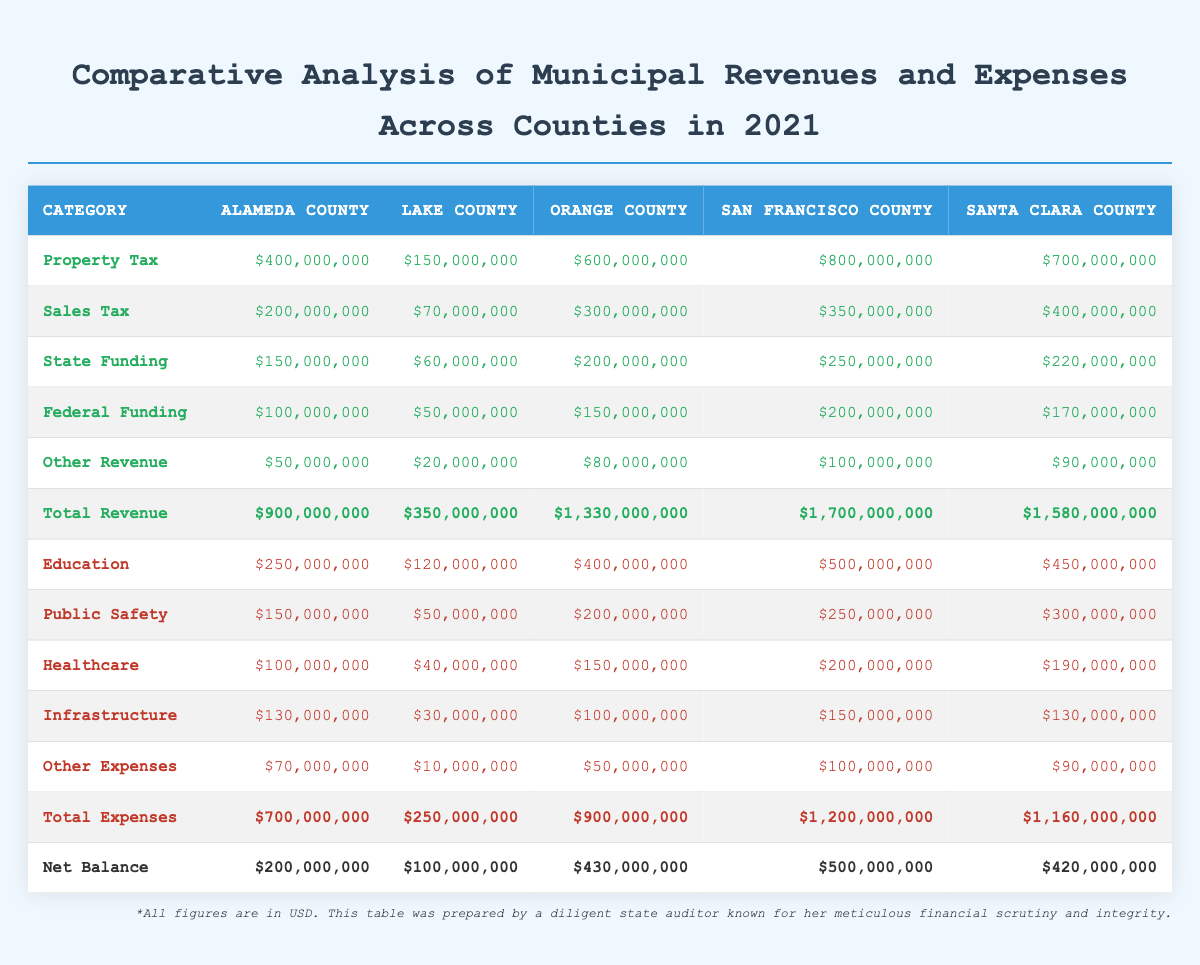What is the total revenue for Orange County? The total revenue for Orange County is provided directly in the table under the "Total Revenue" row, which shows $1,330,000,000.
Answer: 1,330,000,000 Which county has the highest expenditure on education? By examining the "Education" expenses row, San Francisco County has the highest expenditure at $500,000,000.
Answer: San Francisco County What is the difference in total expenses between Santa Clara County and Lake County? Santa Clara County's total expenses are $1,160,000,000 and Lake County's are $250,000,000. The difference is calculated as $1,160,000,000 - $250,000,000 = $910,000,000.
Answer: 910,000,000 Is the total revenue of Alameda County greater than the total revenue of Lake County? Alameda County's total revenue is $900,000,000 while Lake County's is $350,000,000, so yes, Alameda County's total revenue is greater.
Answer: Yes Which county has the highest net balance, and what is that amount? The net balance is calculated under the "Net Balance" row, and San Francisco County has the highest net balance at $500,000,000.
Answer: San Francisco County, 500,000,000 What percentage of Alameda County’s total revenue is sourced from property tax? The property tax for Alameda County is $400,000,000, and total revenue is $900,000,000. The percentage is calculated as ($400,000,000 / $900,000,000) * 100 = approximately 44.44%.
Answer: 44.44% What is the total funding (state and federal) for Santa Clara County? The state funding for Santa Clara County is $220,000,000 and federal funding is $170,000,000. Adding both gives us $220,000,000 + $170,000,000 = $390,000,000.
Answer: 390,000,000 Does any county have more than $1 billion in combined revenue and expenses? For each county, combine their total revenue and total expenses: San Francisco County has $1,700,000,000 + $1,200,000,000 = $2,900,000,000, Santa Clara has $1,580,000,000 + $1,160,000,000 = $2,740,000,000, and Orange County has $1,330,000,000 + $900,000,000 = $2,230,000,000. Yes, several counties exceed $1 billion.
Answer: Yes What is the average total revenue across all counties? Total revenue for all counties is $900,000,000 (Alameda) + $350,000,000 (Lake) + $1,330,000,000 (Orange) + $1,700,000,000 (San Francisco) + $1,580,000,000 (Santa Clara) = $5,860,000,000. There are 5 counties, so the average is $5,860,000,000 / 5 = $1,172,000,000.
Answer: 1,172,000,000 